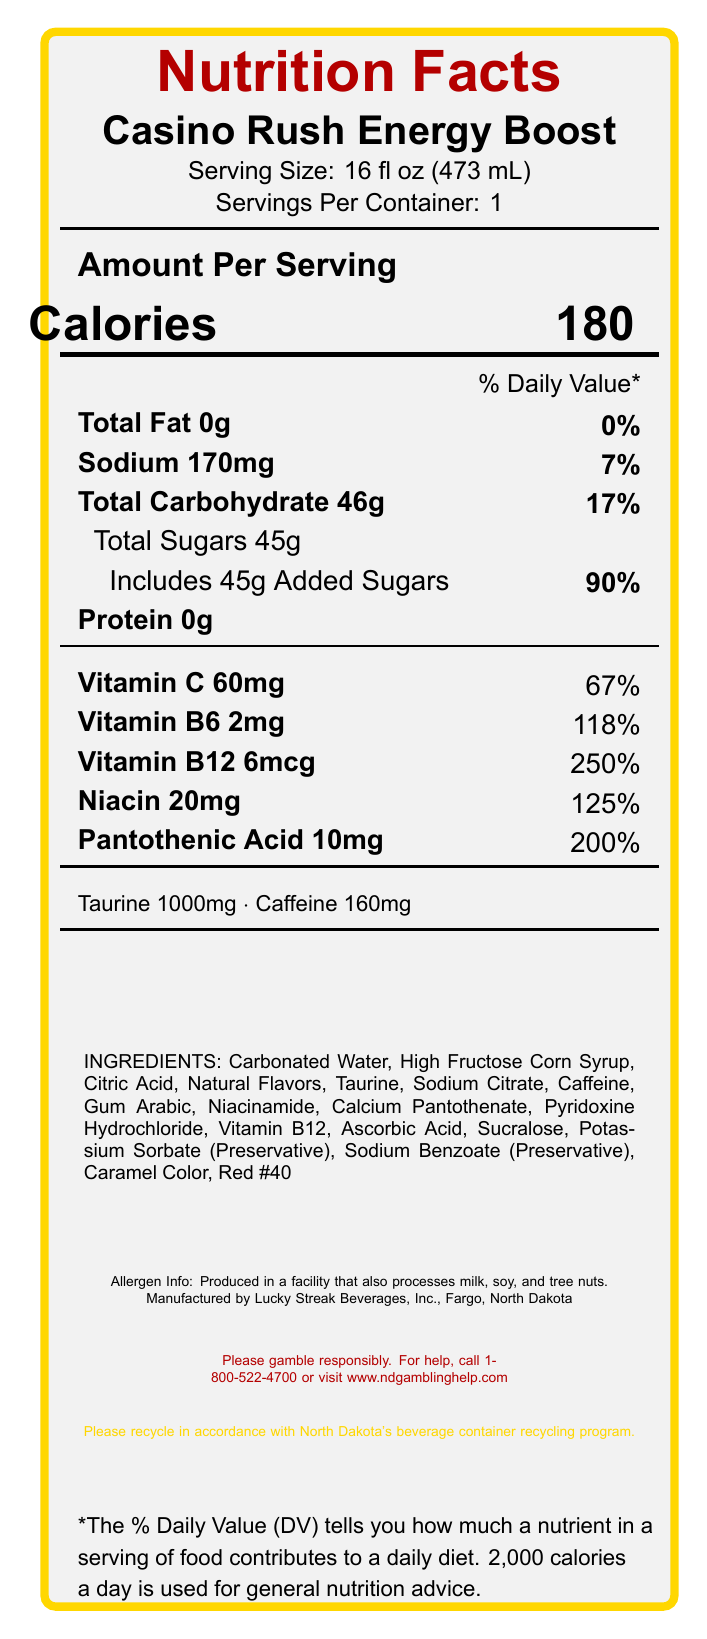what is the serving size of Casino Rush Energy Boost? The serving size is clearly indicated under the product name as "Serving Size: 16 fl oz (473 mL)."
Answer: 16 fl oz (473 mL) how many calories are in one serving of Casino Rush Energy Boost? The calorie content per serving is listed prominently as "Calories 180."
Answer: 180 what is the daily value percentage for total fat? The document lists "Total Fat 0g" followed by "0%" indicating the daily value percentage.
Answer: 0% how much sodium is in a serving of Casino Rush Energy Boost? The amount of sodium is listed as "Sodium 170mg."
Answer: 170mg what is the amount of total carbohydrates per serving? The document states "Total Carbohydrate 46g."
Answer: 46g how many grams of added sugars are in Casino Rush Energy Boost? The label includes "Includes 45g Added Sugars."
Answer: 45g how much Vitamin C is in each serving? The document lists "Vitamin C 60mg."
Answer: 60mg what is the percentage daily value of niacin in a serving? The label states "Niacin 20mg" with a daily value percentage of "125%."
Answer: 125% how many grams of protein are in a serving? A. 1g B. 0g C. 2g D. 3g The label indicates "Protein 0g," meaning it contains no protein.
Answer: B. 0g which ingredient is listed first? A. High Fructose Corn Syrup B. Citric Acid C. Carbonated Water D. Taurine The document lists "Carbonated Water" as the first ingredient.
Answer: C. Carbonated Water how much caffeine is in a serving of Casino Rush Energy Boost? The document states "Caffeine 160mg."
Answer: 160mg is there any allergen information provided on the label? The label mentions "Produced in a facility that also processes milk, soy, and tree nuts."
Answer: Yes what percentage of the daily value of Vitamin B6 does one serving contain? The document lists "Vitamin B6 2mg" with a daily value percentage of "118%."
Answer: 118% what is the main purpose of the responsible gambling statement? The statement is meant to encourage responsible gambling behaviors.
Answer: Encourage responsible gambling what company manufactures Casino Rush Energy Boost? The label specifies the manufacturer as "Lucky Streak Beverages, Inc."
Answer: Lucky Streak Beverages, Inc. where is the manufacturer located? The document states the manufacturing location as "Fargo, North Dakota."
Answer: Fargo, North Dakota please summarize the main details shown in the nutrition label. The document visually presents a detailed breakdown of nutritional content, ingredients, allergen information, and manufacturer details for the product.
Answer: The nutrition label for Casino Rush Energy Boost lists the serving size as 16 fl oz (473 mL) with 180 calories per serving. It contains 0g total fat, 170mg sodium, 46g total carbohydrates, 45g total sugars including 45g added sugars. It also includes vitamins and nutrients like Vitamin C, B6, B12, niacin, and pantothenic acid with their respective daily values. Ingredients and allergen information are also provided. what is the exact address of the manufacturer? The document only lists the city and state (Fargo, North Dakota) but does not provide an exact address.
Answer: Cannot be determined 